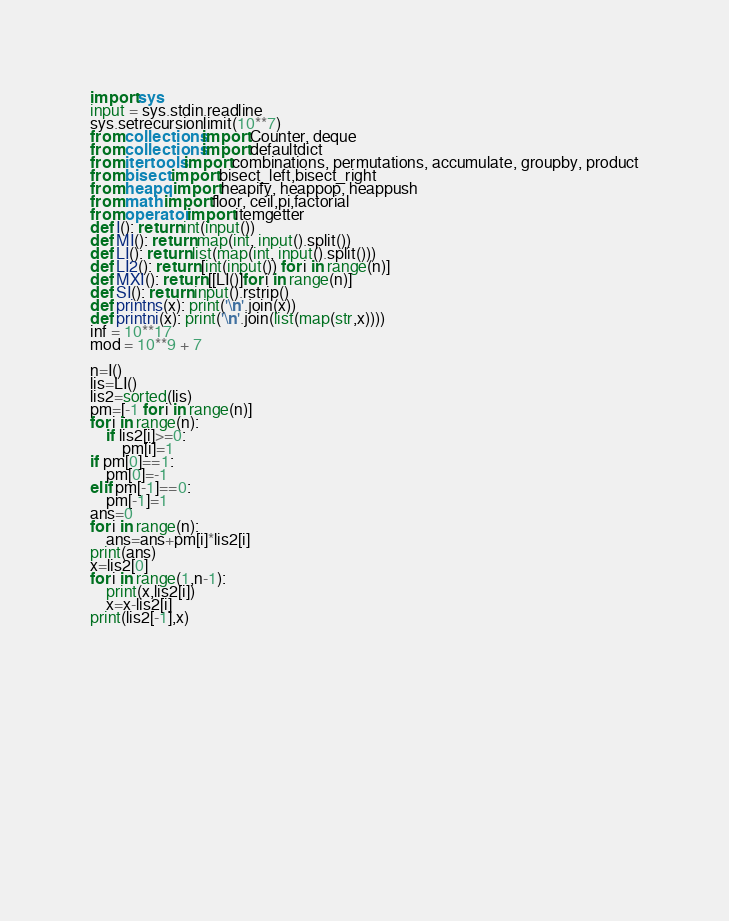<code> <loc_0><loc_0><loc_500><loc_500><_Python_>import sys
input = sys.stdin.readline
sys.setrecursionlimit(10**7)
from collections import Counter, deque
from collections import defaultdict
from itertools import combinations, permutations, accumulate, groupby, product
from bisect import bisect_left,bisect_right
from heapq import heapify, heappop, heappush
from math import floor, ceil,pi,factorial
from operator import itemgetter
def I(): return int(input())
def MI(): return map(int, input().split())
def LI(): return list(map(int, input().split()))
def LI2(): return [int(input()) for i in range(n)]
def MXI(): return [[LI()]for i in range(n)]
def SI(): return input().rstrip()
def printns(x): print('\n'.join(x))
def printni(x): print('\n'.join(list(map(str,x))))
inf = 10**17
mod = 10**9 + 7

n=I()
lis=LI()
lis2=sorted(lis)
pm=[-1 for i in range(n)]
for i in range(n):
    if lis2[i]>=0:
        pm[i]=1
if pm[0]==1:
    pm[0]=-1
elif pm[-1]==0:
    pm[-1]=1
ans=0
for i in range(n):
    ans=ans+pm[i]*lis2[i]
print(ans)
x=lis2[0]
for i in range(1,n-1):
    print(x,lis2[i])
    x=x-lis2[i]
print(lis2[-1],x)
    
        


            
        
        
            
    
            
            

    
    
            
            

</code> 